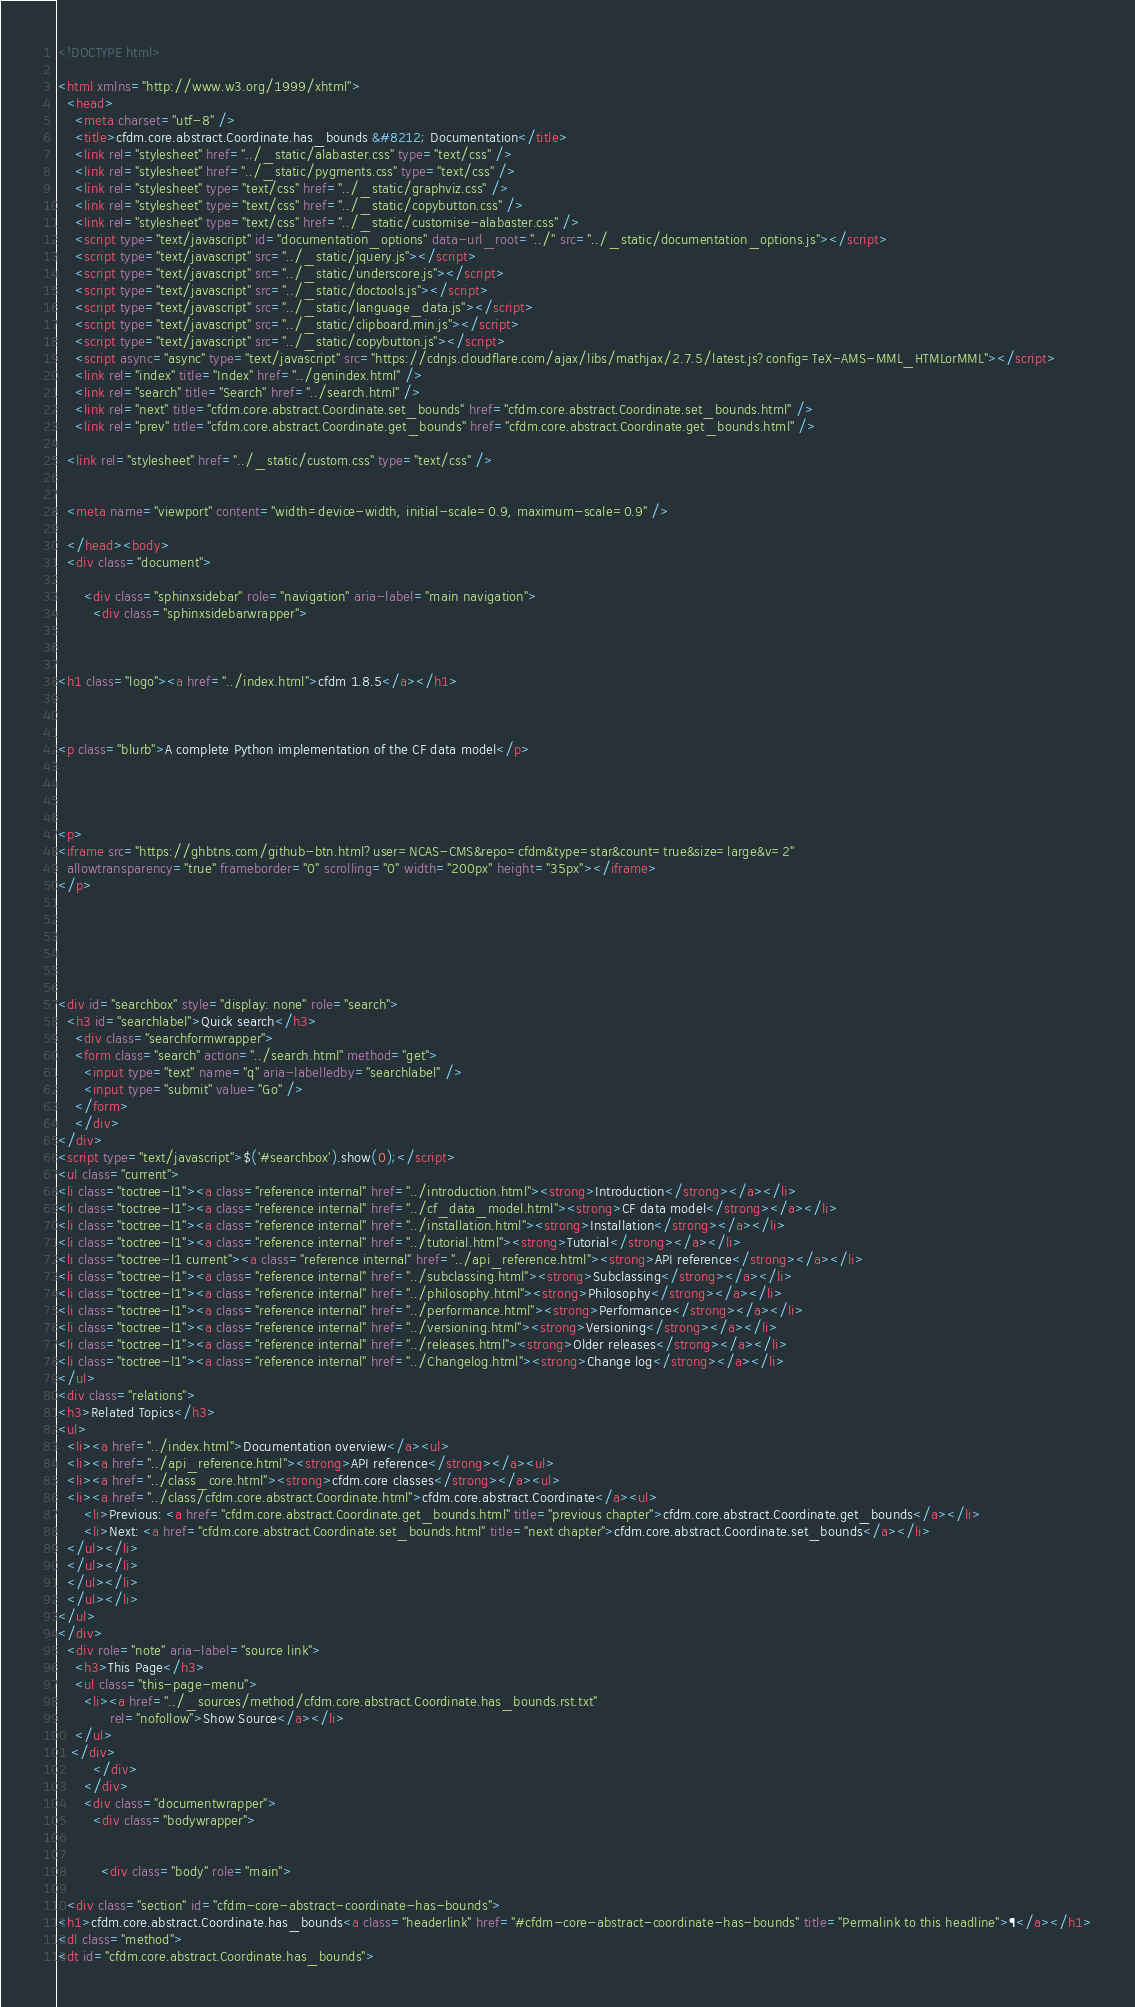Convert code to text. <code><loc_0><loc_0><loc_500><loc_500><_HTML_>
<!DOCTYPE html>

<html xmlns="http://www.w3.org/1999/xhtml">
  <head>
    <meta charset="utf-8" />
    <title>cfdm.core.abstract.Coordinate.has_bounds &#8212; Documentation</title>
    <link rel="stylesheet" href="../_static/alabaster.css" type="text/css" />
    <link rel="stylesheet" href="../_static/pygments.css" type="text/css" />
    <link rel="stylesheet" type="text/css" href="../_static/graphviz.css" />
    <link rel="stylesheet" type="text/css" href="../_static/copybutton.css" />
    <link rel="stylesheet" type="text/css" href="../_static/customise-alabaster.css" />
    <script type="text/javascript" id="documentation_options" data-url_root="../" src="../_static/documentation_options.js"></script>
    <script type="text/javascript" src="../_static/jquery.js"></script>
    <script type="text/javascript" src="../_static/underscore.js"></script>
    <script type="text/javascript" src="../_static/doctools.js"></script>
    <script type="text/javascript" src="../_static/language_data.js"></script>
    <script type="text/javascript" src="../_static/clipboard.min.js"></script>
    <script type="text/javascript" src="../_static/copybutton.js"></script>
    <script async="async" type="text/javascript" src="https://cdnjs.cloudflare.com/ajax/libs/mathjax/2.7.5/latest.js?config=TeX-AMS-MML_HTMLorMML"></script>
    <link rel="index" title="Index" href="../genindex.html" />
    <link rel="search" title="Search" href="../search.html" />
    <link rel="next" title="cfdm.core.abstract.Coordinate.set_bounds" href="cfdm.core.abstract.Coordinate.set_bounds.html" />
    <link rel="prev" title="cfdm.core.abstract.Coordinate.get_bounds" href="cfdm.core.abstract.Coordinate.get_bounds.html" />
   
  <link rel="stylesheet" href="../_static/custom.css" type="text/css" />
  
  
  <meta name="viewport" content="width=device-width, initial-scale=0.9, maximum-scale=0.9" />

  </head><body>
  <div class="document">
    
      <div class="sphinxsidebar" role="navigation" aria-label="main navigation">
        <div class="sphinxsidebarwrapper">



<h1 class="logo"><a href="../index.html">cfdm 1.8.5</a></h1>



<p class="blurb">A complete Python implementation of the CF data model</p>




<p>
<iframe src="https://ghbtns.com/github-btn.html?user=NCAS-CMS&repo=cfdm&type=star&count=true&size=large&v=2"
  allowtransparency="true" frameborder="0" scrolling="0" width="200px" height="35px"></iframe>
</p>






<div id="searchbox" style="display: none" role="search">
  <h3 id="searchlabel">Quick search</h3>
    <div class="searchformwrapper">
    <form class="search" action="../search.html" method="get">
      <input type="text" name="q" aria-labelledby="searchlabel" />
      <input type="submit" value="Go" />
    </form>
    </div>
</div>
<script type="text/javascript">$('#searchbox').show(0);</script>
<ul class="current">
<li class="toctree-l1"><a class="reference internal" href="../introduction.html"><strong>Introduction</strong></a></li>
<li class="toctree-l1"><a class="reference internal" href="../cf_data_model.html"><strong>CF data model</strong></a></li>
<li class="toctree-l1"><a class="reference internal" href="../installation.html"><strong>Installation</strong></a></li>
<li class="toctree-l1"><a class="reference internal" href="../tutorial.html"><strong>Tutorial</strong></a></li>
<li class="toctree-l1 current"><a class="reference internal" href="../api_reference.html"><strong>API reference</strong></a></li>
<li class="toctree-l1"><a class="reference internal" href="../subclassing.html"><strong>Subclassing</strong></a></li>
<li class="toctree-l1"><a class="reference internal" href="../philosophy.html"><strong>Philosophy</strong></a></li>
<li class="toctree-l1"><a class="reference internal" href="../performance.html"><strong>Performance</strong></a></li>
<li class="toctree-l1"><a class="reference internal" href="../versioning.html"><strong>Versioning</strong></a></li>
<li class="toctree-l1"><a class="reference internal" href="../releases.html"><strong>Older releases</strong></a></li>
<li class="toctree-l1"><a class="reference internal" href="../Changelog.html"><strong>Change log</strong></a></li>
</ul>
<div class="relations">
<h3>Related Topics</h3>
<ul>
  <li><a href="../index.html">Documentation overview</a><ul>
  <li><a href="../api_reference.html"><strong>API reference</strong></a><ul>
  <li><a href="../class_core.html"><strong>cfdm.core classes</strong></a><ul>
  <li><a href="../class/cfdm.core.abstract.Coordinate.html">cfdm.core.abstract.Coordinate</a><ul>
      <li>Previous: <a href="cfdm.core.abstract.Coordinate.get_bounds.html" title="previous chapter">cfdm.core.abstract.Coordinate.get_bounds</a></li>
      <li>Next: <a href="cfdm.core.abstract.Coordinate.set_bounds.html" title="next chapter">cfdm.core.abstract.Coordinate.set_bounds</a></li>
  </ul></li>
  </ul></li>
  </ul></li>
  </ul></li>
</ul>
</div>
  <div role="note" aria-label="source link">
    <h3>This Page</h3>
    <ul class="this-page-menu">
      <li><a href="../_sources/method/cfdm.core.abstract.Coordinate.has_bounds.rst.txt"
            rel="nofollow">Show Source</a></li>
    </ul>
   </div>
        </div>
      </div>
      <div class="documentwrapper">
        <div class="bodywrapper">
          

          <div class="body" role="main">
            
  <div class="section" id="cfdm-core-abstract-coordinate-has-bounds">
<h1>cfdm.core.abstract.Coordinate.has_bounds<a class="headerlink" href="#cfdm-core-abstract-coordinate-has-bounds" title="Permalink to this headline">¶</a></h1>
<dl class="method">
<dt id="cfdm.core.abstract.Coordinate.has_bounds"></code> 